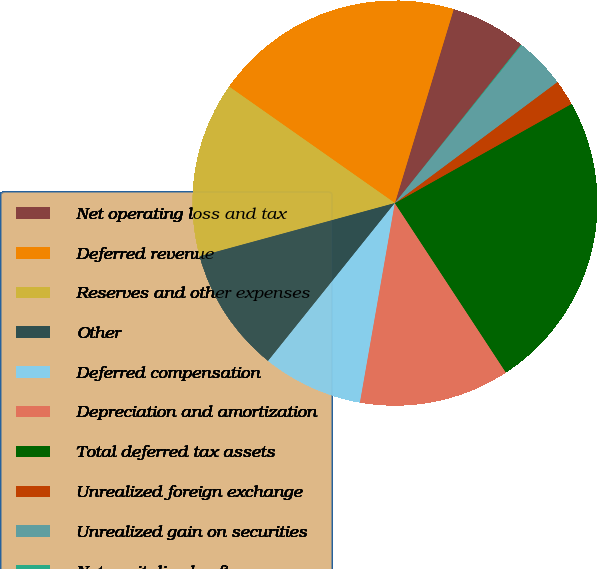Convert chart. <chart><loc_0><loc_0><loc_500><loc_500><pie_chart><fcel>Net operating loss and tax<fcel>Deferred revenue<fcel>Reserves and other expenses<fcel>Other<fcel>Deferred compensation<fcel>Depreciation and amortization<fcel>Total deferred tax assets<fcel>Unrealized foreign exchange<fcel>Unrealized gain on securities<fcel>Net capitalized software<nl><fcel>6.02%<fcel>19.94%<fcel>13.98%<fcel>10.0%<fcel>8.01%<fcel>11.99%<fcel>23.91%<fcel>2.05%<fcel>4.04%<fcel>0.06%<nl></chart> 